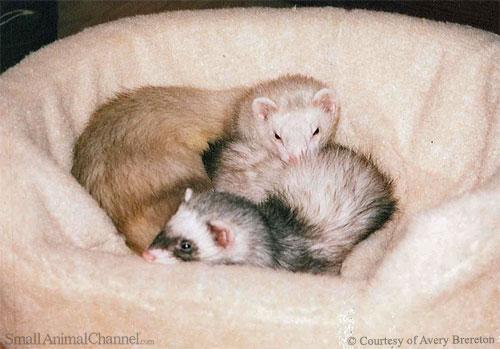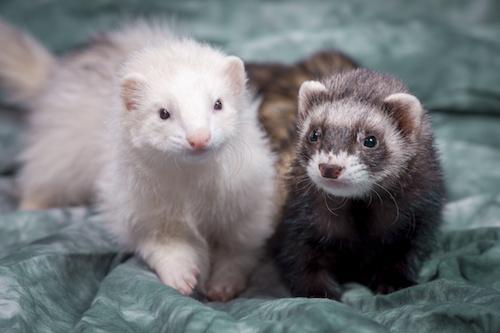The first image is the image on the left, the second image is the image on the right. For the images displayed, is the sentence "a pair of ferrets are next to each other on top of draped fabric" factually correct? Answer yes or no. Yes. The first image is the image on the left, the second image is the image on the right. Evaluate the accuracy of this statement regarding the images: "At least one guinea pig is cleaning another's face.". Is it true? Answer yes or no. No. 